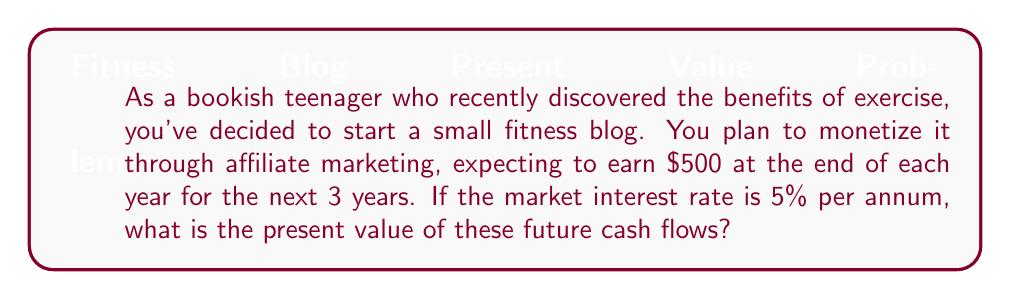Could you help me with this problem? To solve this problem, we need to use the discounted cash flow (DCF) analysis. The formula for the present value (PV) of a series of future cash flows is:

$$PV = \sum_{t=1}^{n} \frac{CF_t}{(1+r)^t}$$

Where:
$CF_t$ = Cash flow at time t
$r$ = Discount rate (interest rate)
$n$ = Number of periods

In this case:
$CF_t = \$500$ for all t
$r = 5\% = 0.05$
$n = 3$ years

Let's calculate the present value for each year:

Year 1: $PV_1 = \frac{\$500}{(1+0.05)^1} = \frac{\$500}{1.05} = \$476.19$

Year 2: $PV_2 = \frac{\$500}{(1+0.05)^2} = \frac{\$500}{1.1025} = \$453.51$

Year 3: $PV_3 = \frac{\$500}{(1+0.05)^3} = \frac{\$500}{1.157625} = \$431.92$

Now, we sum up these individual present values:

$PV_{total} = PV_1 + PV_2 + PV_3 = \$476.19 + \$453.51 + \$431.92 = \$1,361.62$

Therefore, the present value of the future cash flows is $1,361.62.
Answer: $1,361.62 